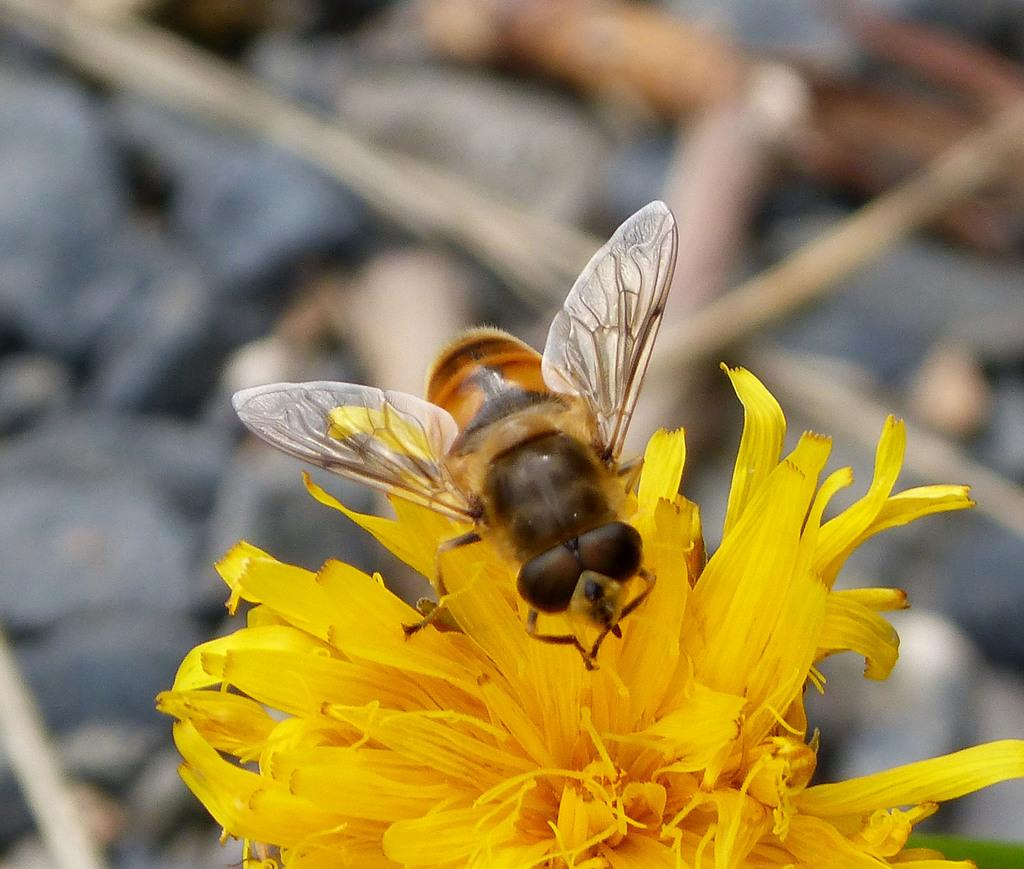What is the main subject of the image? There is an insect in the image. Where is the insect located? The insect is lying on a flower. How is the background of the image depicted? The background of the insect is blurred. What type of haircut does the insect have in the image? There is no indication of a haircut in the image, as insects do not have hair. 